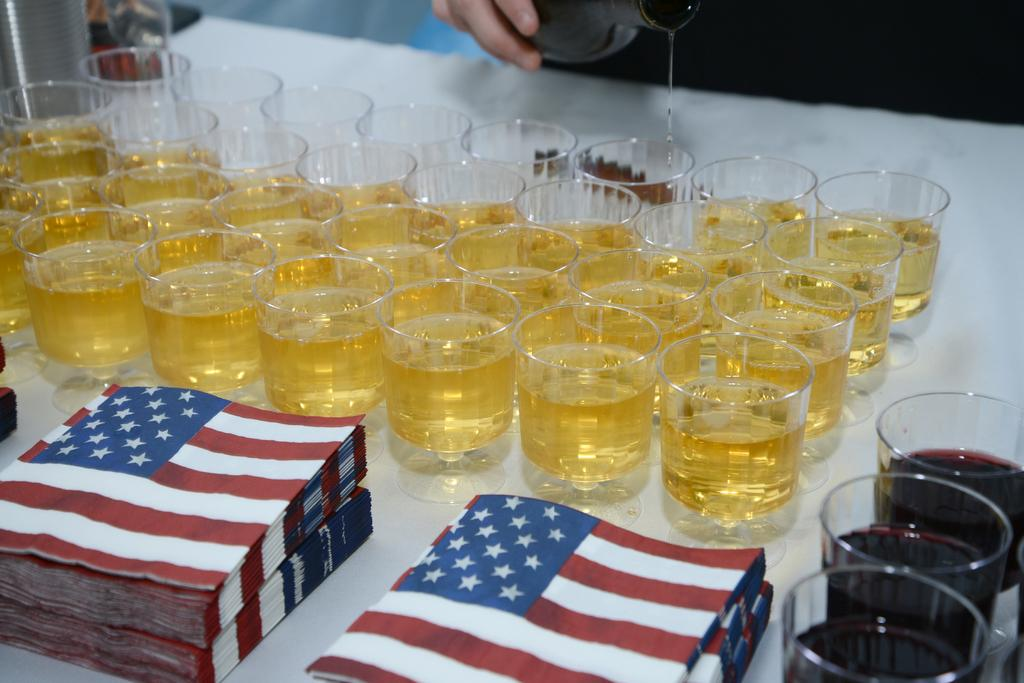What type of containers are holding the beverages in the image? There are beverages in tumblers in the image. What can be used for cleaning or wiping in the image? Tissues are present on the table in the image. What part of a person can be seen at the top of the image? There is a human hand at the top of the image. What is located at the top of the image besides the hand? There is a bottle at the top of the image. What channel is the person watching on the television in the image? There is no television present in the image, so it is not possible to determine what channel the person might be watching. 